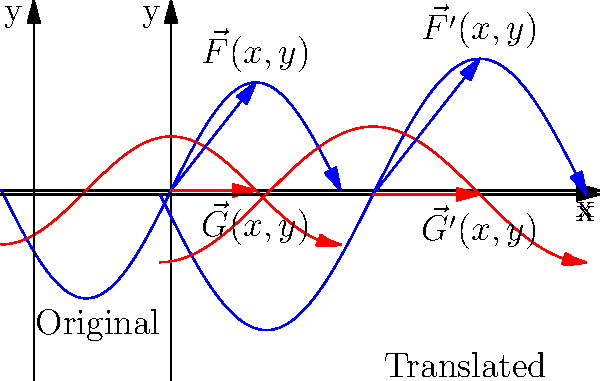In a bioreactor for anaerobic digestion, the fluid flow can be represented by a vector field $\vec{F}(x,y) = 2\sin(x)\hat{i} + \cos(y)\hat{j}$. If this vector field is translated 5 units in the positive x-direction, what is the new representation of the vector field $\vec{F'}(x,y)$? To solve this problem, we need to understand how translation affects a vector field:

1) The original vector field is given as:
   $\vec{F}(x,y) = 2\sin(x)\hat{i} + \cos(y)\hat{j}$

2) Translation by 5 units in the positive x-direction means replacing every x with (x-5):
   $\vec{F'}(x,y) = 2\sin(x-5)\hat{i} + \cos(y)\hat{j}$

3) Note that the y-component remains unchanged because the translation is only in the x-direction.

4) In the diagram, we can see the original vector field (left) and the translated vector field (right). The blue curve represents the x-component, and the red curve represents the y-component.

5) The translation shifts the entire x-component of the vector field 5 units to the right, while the y-component remains in the same position relative to the y-axis.

6) This transformation is important in bioreactor design as it allows us to model how fluid flow patterns change when we adjust the geometry or input locations of the reactor.
Answer: $\vec{F'}(x,y) = 2\sin(x-5)\hat{i} + \cos(y)\hat{j}$ 